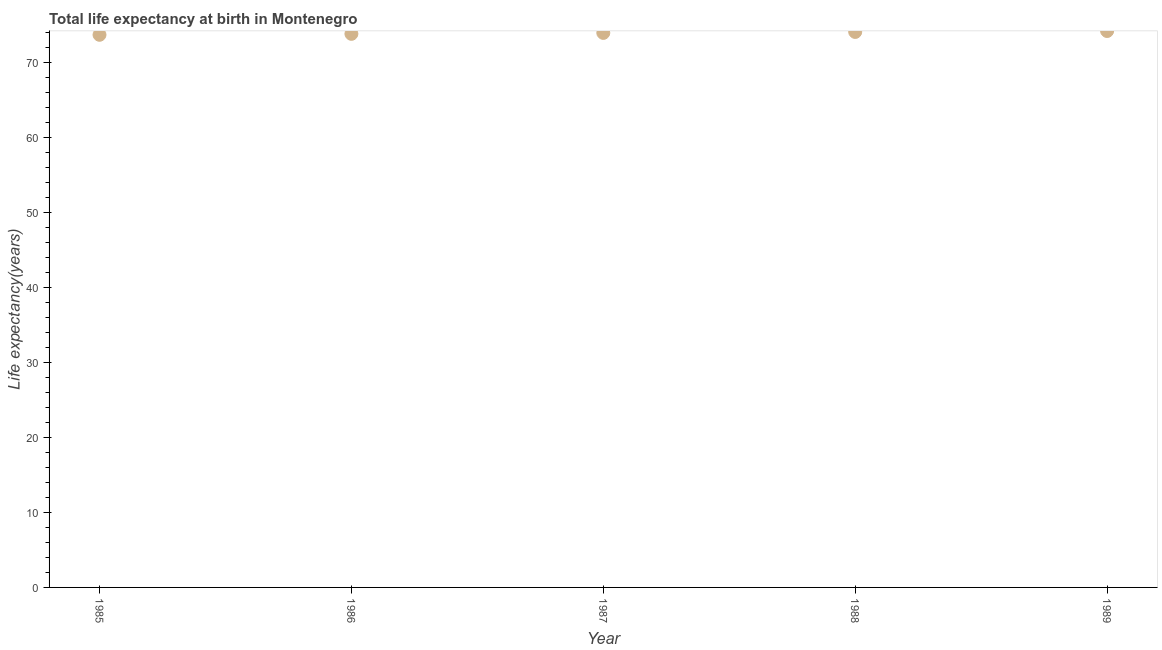What is the life expectancy at birth in 1988?
Your answer should be compact. 74.09. Across all years, what is the maximum life expectancy at birth?
Make the answer very short. 74.21. Across all years, what is the minimum life expectancy at birth?
Provide a short and direct response. 73.71. What is the sum of the life expectancy at birth?
Give a very brief answer. 369.8. What is the difference between the life expectancy at birth in 1985 and 1987?
Give a very brief answer. -0.25. What is the average life expectancy at birth per year?
Keep it short and to the point. 73.96. What is the median life expectancy at birth?
Offer a terse response. 73.96. Do a majority of the years between 1988 and 1989 (inclusive) have life expectancy at birth greater than 68 years?
Make the answer very short. Yes. What is the ratio of the life expectancy at birth in 1986 to that in 1989?
Ensure brevity in your answer.  0.99. Is the life expectancy at birth in 1985 less than that in 1989?
Give a very brief answer. Yes. Is the difference between the life expectancy at birth in 1985 and 1987 greater than the difference between any two years?
Offer a terse response. No. What is the difference between the highest and the second highest life expectancy at birth?
Offer a terse response. 0.13. Is the sum of the life expectancy at birth in 1985 and 1989 greater than the maximum life expectancy at birth across all years?
Provide a short and direct response. Yes. What is the difference between the highest and the lowest life expectancy at birth?
Make the answer very short. 0.51. In how many years, is the life expectancy at birth greater than the average life expectancy at birth taken over all years?
Give a very brief answer. 3. Does the graph contain any zero values?
Provide a short and direct response. No. What is the title of the graph?
Provide a short and direct response. Total life expectancy at birth in Montenegro. What is the label or title of the Y-axis?
Provide a succinct answer. Life expectancy(years). What is the Life expectancy(years) in 1985?
Offer a very short reply. 73.71. What is the Life expectancy(years) in 1986?
Make the answer very short. 73.83. What is the Life expectancy(years) in 1987?
Make the answer very short. 73.96. What is the Life expectancy(years) in 1988?
Make the answer very short. 74.09. What is the Life expectancy(years) in 1989?
Give a very brief answer. 74.21. What is the difference between the Life expectancy(years) in 1985 and 1986?
Offer a very short reply. -0.13. What is the difference between the Life expectancy(years) in 1985 and 1987?
Ensure brevity in your answer.  -0.25. What is the difference between the Life expectancy(years) in 1985 and 1988?
Your answer should be very brief. -0.38. What is the difference between the Life expectancy(years) in 1985 and 1989?
Your response must be concise. -0.51. What is the difference between the Life expectancy(years) in 1986 and 1987?
Give a very brief answer. -0.13. What is the difference between the Life expectancy(years) in 1986 and 1988?
Keep it short and to the point. -0.25. What is the difference between the Life expectancy(years) in 1986 and 1989?
Provide a succinct answer. -0.38. What is the difference between the Life expectancy(years) in 1987 and 1988?
Offer a terse response. -0.13. What is the difference between the Life expectancy(years) in 1987 and 1989?
Provide a short and direct response. -0.25. What is the difference between the Life expectancy(years) in 1988 and 1989?
Keep it short and to the point. -0.13. What is the ratio of the Life expectancy(years) in 1985 to that in 1986?
Your answer should be very brief. 1. What is the ratio of the Life expectancy(years) in 1985 to that in 1988?
Your answer should be compact. 0.99. What is the ratio of the Life expectancy(years) in 1985 to that in 1989?
Give a very brief answer. 0.99. What is the ratio of the Life expectancy(years) in 1986 to that in 1988?
Your response must be concise. 1. What is the ratio of the Life expectancy(years) in 1986 to that in 1989?
Make the answer very short. 0.99. 